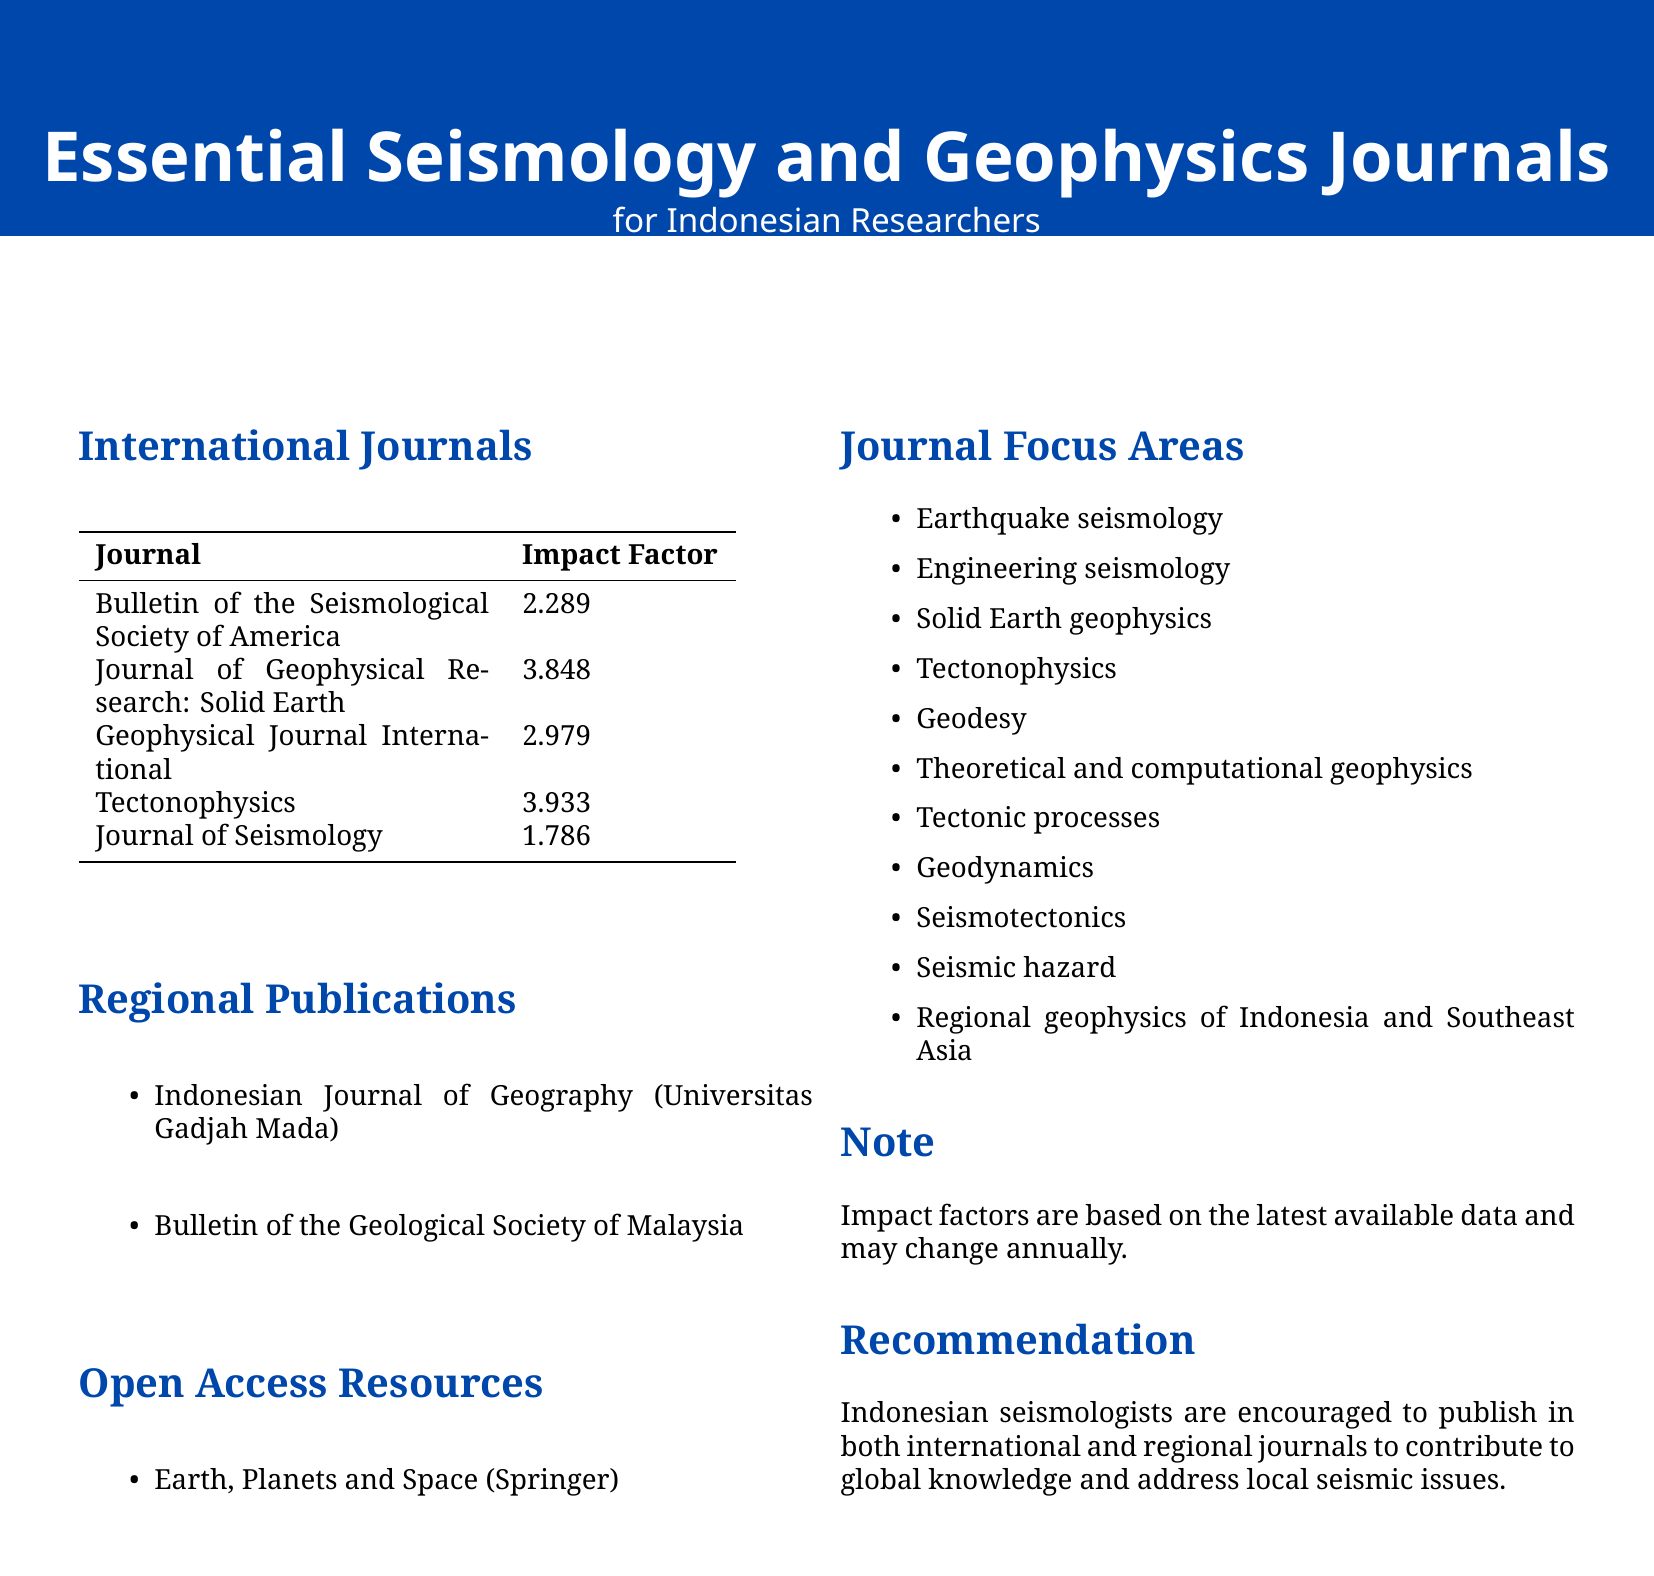What is the title of the document? The title of the document is found at the top, highlighting its focus on seismology and geophysics journals.
Answer: Essential Seismology and Geophysics Journals How many international journals are listed? The document provides a clear count of international journals in the respective section.
Answer: 5 What is the Impact Factor of the Journal of Geophysical Research: Solid Earth? The impact factors for each journal are presented in a table format, making it easy to find this information.
Answer: 3.848 Which journal is an open access resource? Open access resources are specifically mentioned in their section, identifying them for easy reference.
Answer: Earth, Planets and Space What focus area related to seismology is included in the document? The document lists multiple focus areas relevant to seismology and geophysics in a categorized manner.
Answer: Earthquake seismology Are regional publications mentioned in the document? The document explicitly specifies a section for regional publications, confirming their inclusion.
Answer: Yes Which university hosts the Indonesian Journal of Geography? The document states the hosting institution for this publication within its regional publications section.
Answer: Universitas Gadjah Mada What does the recommendation section encourage Indonesian seismologists to do? The recommendation section summarizes the document’s advice for Indonesian seismologists, which is clear and direct.
Answer: Publish in both international and regional journals 